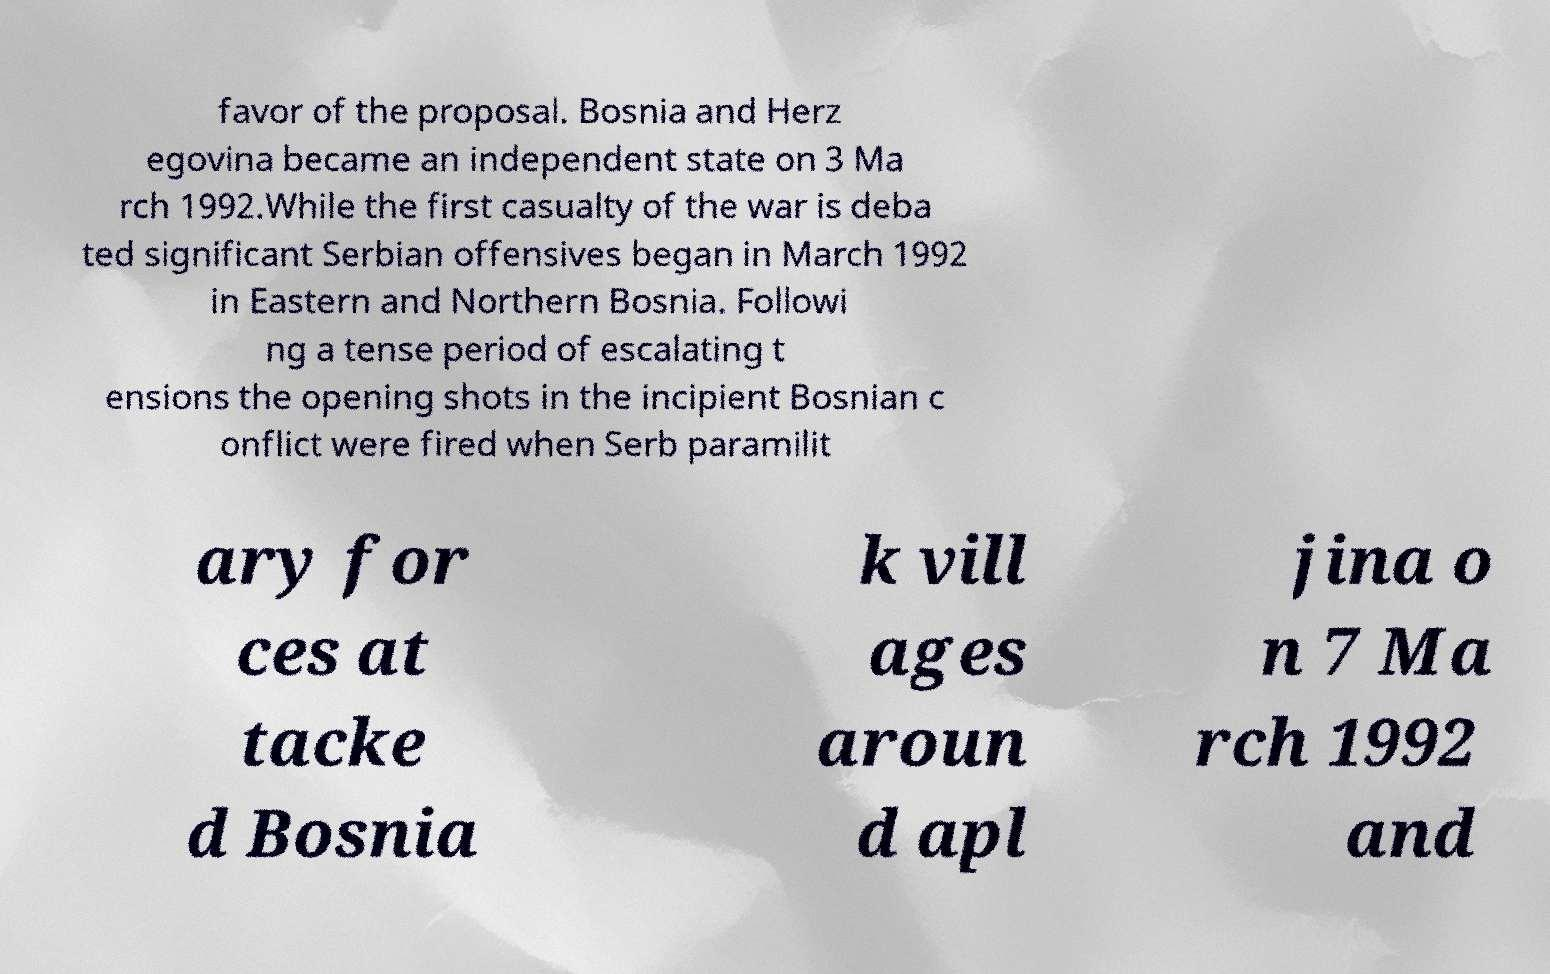There's text embedded in this image that I need extracted. Can you transcribe it verbatim? favor of the proposal. Bosnia and Herz egovina became an independent state on 3 Ma rch 1992.While the first casualty of the war is deba ted significant Serbian offensives began in March 1992 in Eastern and Northern Bosnia. Followi ng a tense period of escalating t ensions the opening shots in the incipient Bosnian c onflict were fired when Serb paramilit ary for ces at tacke d Bosnia k vill ages aroun d apl jina o n 7 Ma rch 1992 and 